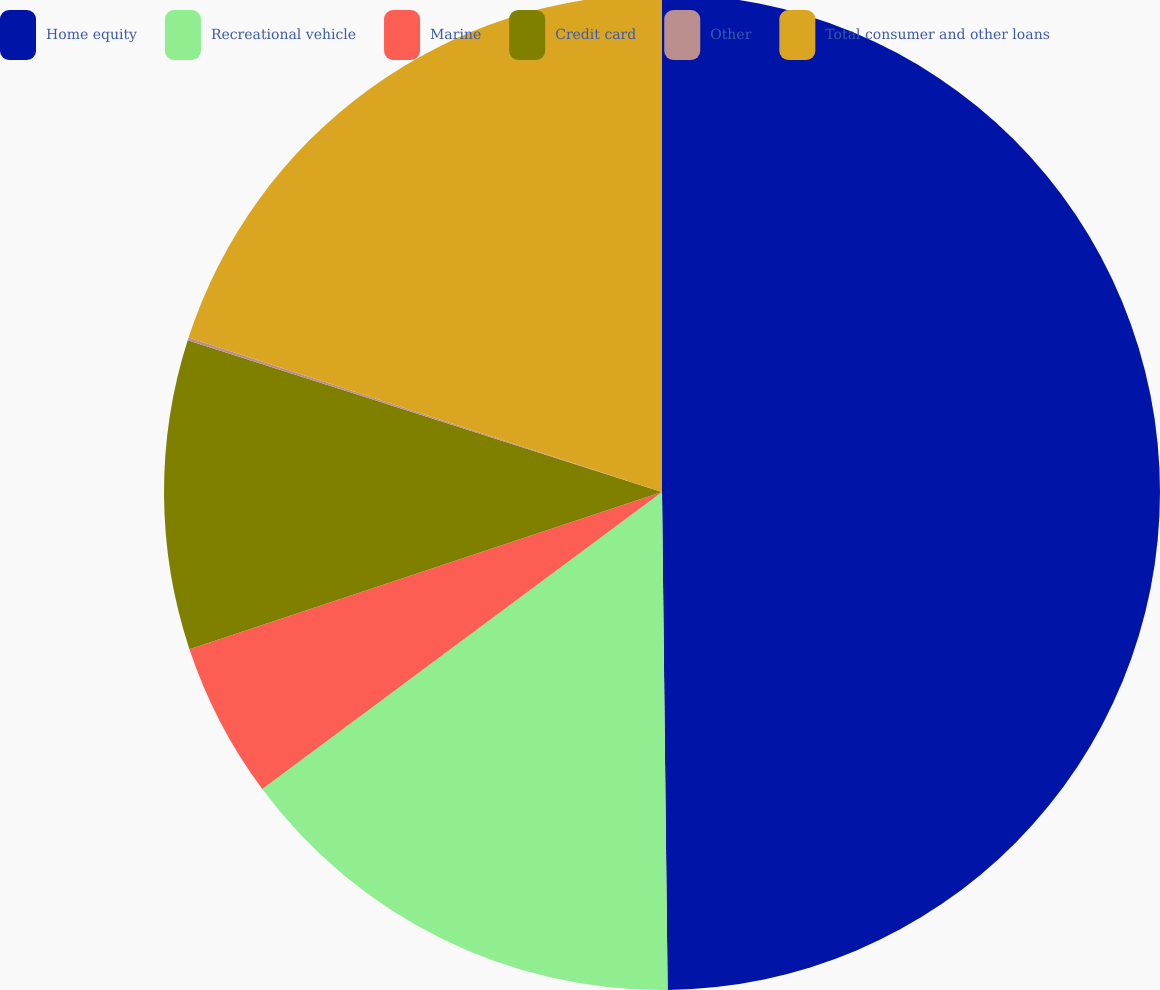Convert chart. <chart><loc_0><loc_0><loc_500><loc_500><pie_chart><fcel>Home equity<fcel>Recreational vehicle<fcel>Marine<fcel>Credit card<fcel>Other<fcel>Total consumer and other loans<nl><fcel>49.82%<fcel>15.01%<fcel>5.06%<fcel>10.04%<fcel>0.09%<fcel>19.98%<nl></chart> 